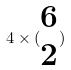<formula> <loc_0><loc_0><loc_500><loc_500>4 \times ( \begin{matrix} 6 \\ 2 \end{matrix} )</formula> 